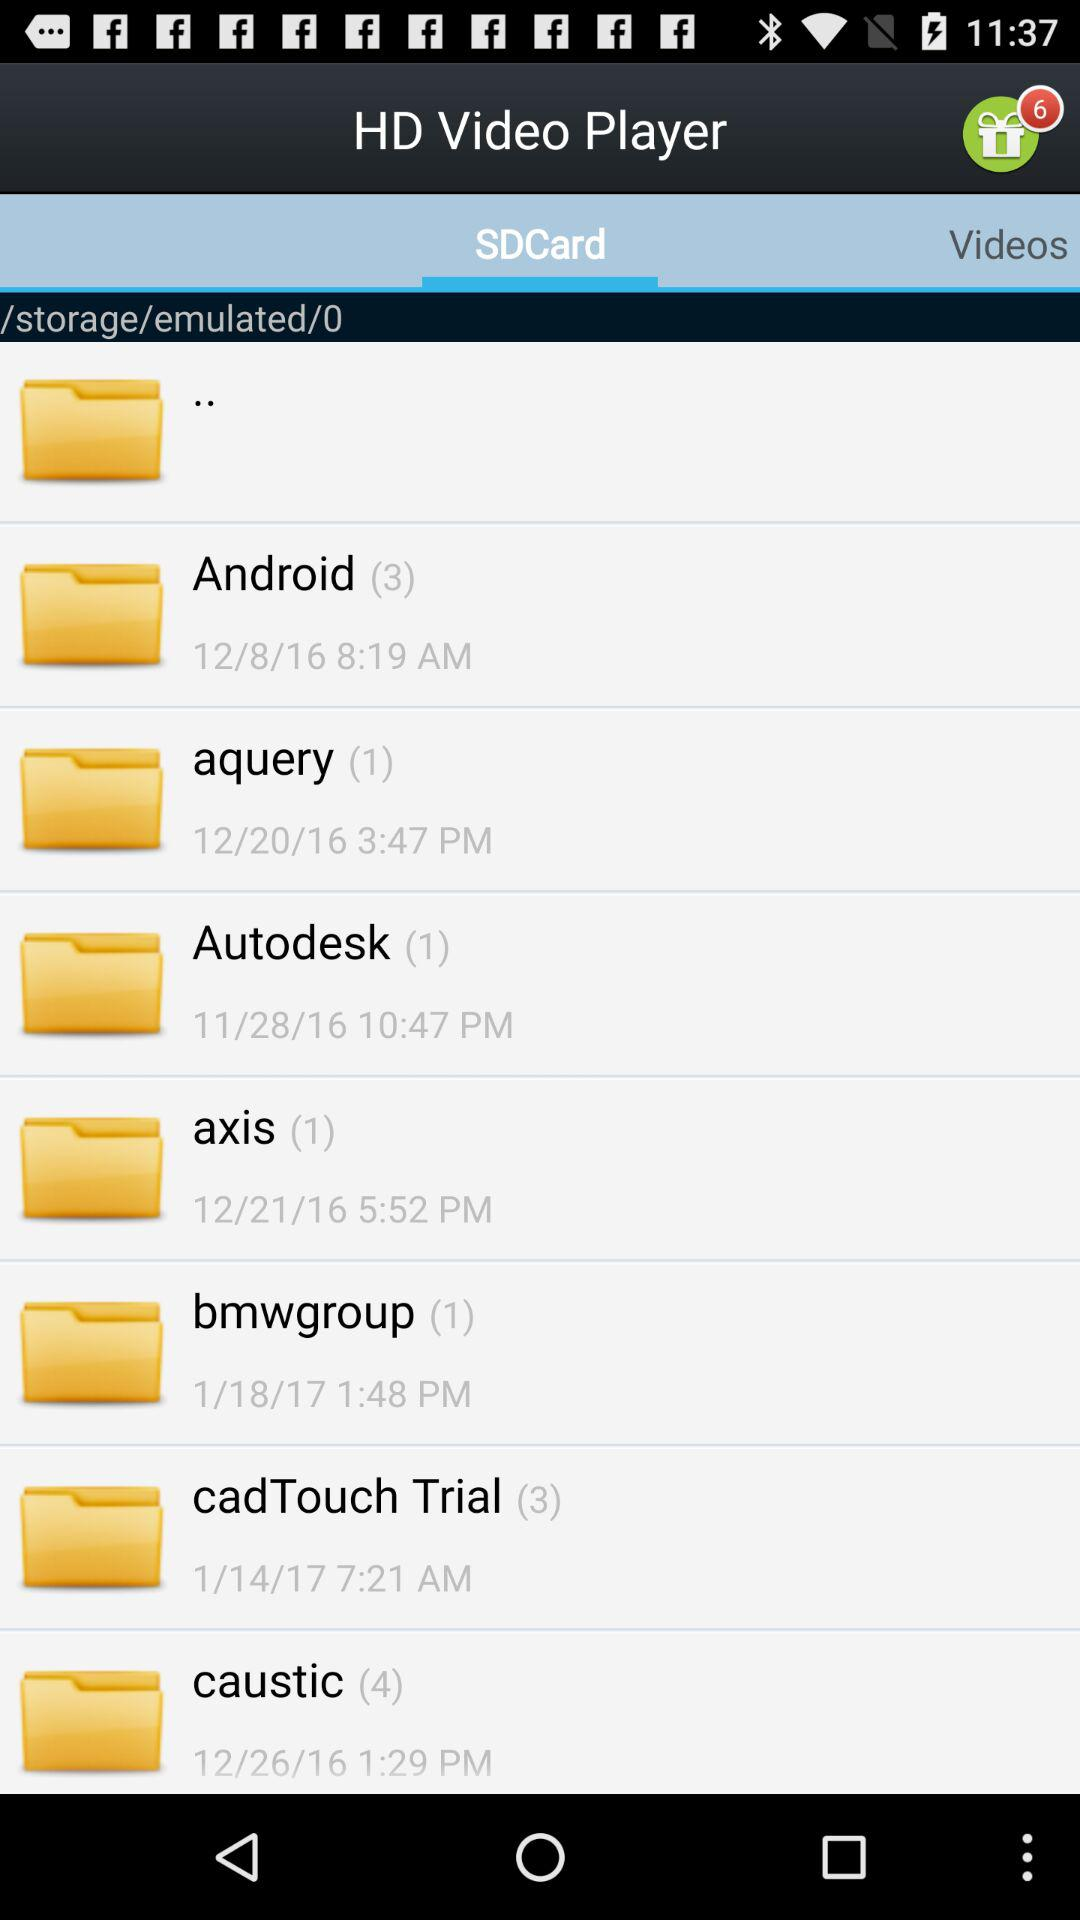What date is shown for Android? The date is December 8, 2016. 